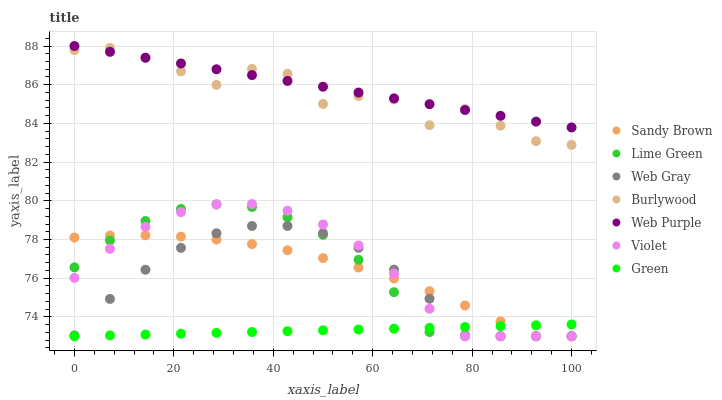Does Green have the minimum area under the curve?
Answer yes or no. Yes. Does Web Purple have the maximum area under the curve?
Answer yes or no. Yes. Does Burlywood have the minimum area under the curve?
Answer yes or no. No. Does Burlywood have the maximum area under the curve?
Answer yes or no. No. Is Green the smoothest?
Answer yes or no. Yes. Is Burlywood the roughest?
Answer yes or no. Yes. Is Sandy Brown the smoothest?
Answer yes or no. No. Is Sandy Brown the roughest?
Answer yes or no. No. Does Web Gray have the lowest value?
Answer yes or no. Yes. Does Burlywood have the lowest value?
Answer yes or no. No. Does Web Purple have the highest value?
Answer yes or no. Yes. Does Burlywood have the highest value?
Answer yes or no. No. Is Green less than Web Purple?
Answer yes or no. Yes. Is Web Purple greater than Lime Green?
Answer yes or no. Yes. Does Violet intersect Web Gray?
Answer yes or no. Yes. Is Violet less than Web Gray?
Answer yes or no. No. Is Violet greater than Web Gray?
Answer yes or no. No. Does Green intersect Web Purple?
Answer yes or no. No. 